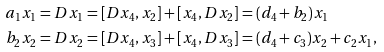Convert formula to latex. <formula><loc_0><loc_0><loc_500><loc_500>a _ { 1 } x _ { 1 } & = D x _ { 1 } = [ D x _ { 4 } , x _ { 2 } ] + [ x _ { 4 } , D x _ { 2 } ] = ( d _ { 4 } + b _ { 2 } ) x _ { 1 } \\ b _ { 2 } x _ { 2 } & = D x _ { 2 } = [ D x _ { 4 } , x _ { 3 } ] + [ x _ { 4 } , D x _ { 3 } ] = ( d _ { 4 } + c _ { 3 } ) x _ { 2 } + c _ { 2 } x _ { 1 } ,</formula> 